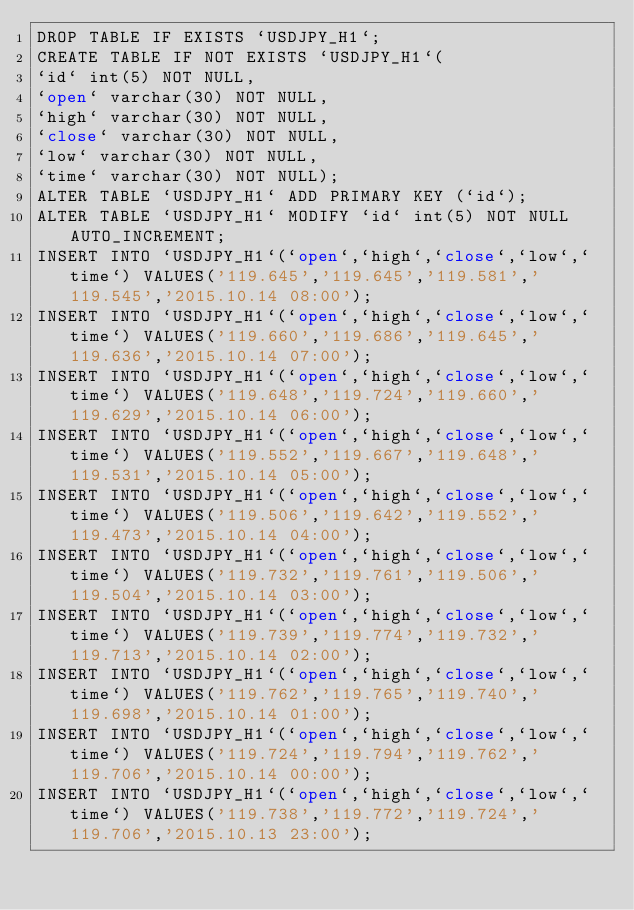<code> <loc_0><loc_0><loc_500><loc_500><_SQL_>DROP TABLE IF EXISTS `USDJPY_H1`;
CREATE TABLE IF NOT EXISTS `USDJPY_H1`(
`id` int(5) NOT NULL,
`open` varchar(30) NOT NULL,
`high` varchar(30) NOT NULL,
`close` varchar(30) NOT NULL,
`low` varchar(30) NOT NULL,
`time` varchar(30) NOT NULL);
ALTER TABLE `USDJPY_H1` ADD PRIMARY KEY (`id`);
ALTER TABLE `USDJPY_H1` MODIFY `id` int(5) NOT NULL AUTO_INCREMENT;
INSERT INTO `USDJPY_H1`(`open`,`high`,`close`,`low`,`time`) VALUES('119.645','119.645','119.581','119.545','2015.10.14 08:00');
INSERT INTO `USDJPY_H1`(`open`,`high`,`close`,`low`,`time`) VALUES('119.660','119.686','119.645','119.636','2015.10.14 07:00');
INSERT INTO `USDJPY_H1`(`open`,`high`,`close`,`low`,`time`) VALUES('119.648','119.724','119.660','119.629','2015.10.14 06:00');
INSERT INTO `USDJPY_H1`(`open`,`high`,`close`,`low`,`time`) VALUES('119.552','119.667','119.648','119.531','2015.10.14 05:00');
INSERT INTO `USDJPY_H1`(`open`,`high`,`close`,`low`,`time`) VALUES('119.506','119.642','119.552','119.473','2015.10.14 04:00');
INSERT INTO `USDJPY_H1`(`open`,`high`,`close`,`low`,`time`) VALUES('119.732','119.761','119.506','119.504','2015.10.14 03:00');
INSERT INTO `USDJPY_H1`(`open`,`high`,`close`,`low`,`time`) VALUES('119.739','119.774','119.732','119.713','2015.10.14 02:00');
INSERT INTO `USDJPY_H1`(`open`,`high`,`close`,`low`,`time`) VALUES('119.762','119.765','119.740','119.698','2015.10.14 01:00');
INSERT INTO `USDJPY_H1`(`open`,`high`,`close`,`low`,`time`) VALUES('119.724','119.794','119.762','119.706','2015.10.14 00:00');
INSERT INTO `USDJPY_H1`(`open`,`high`,`close`,`low`,`time`) VALUES('119.738','119.772','119.724','119.706','2015.10.13 23:00');</code> 